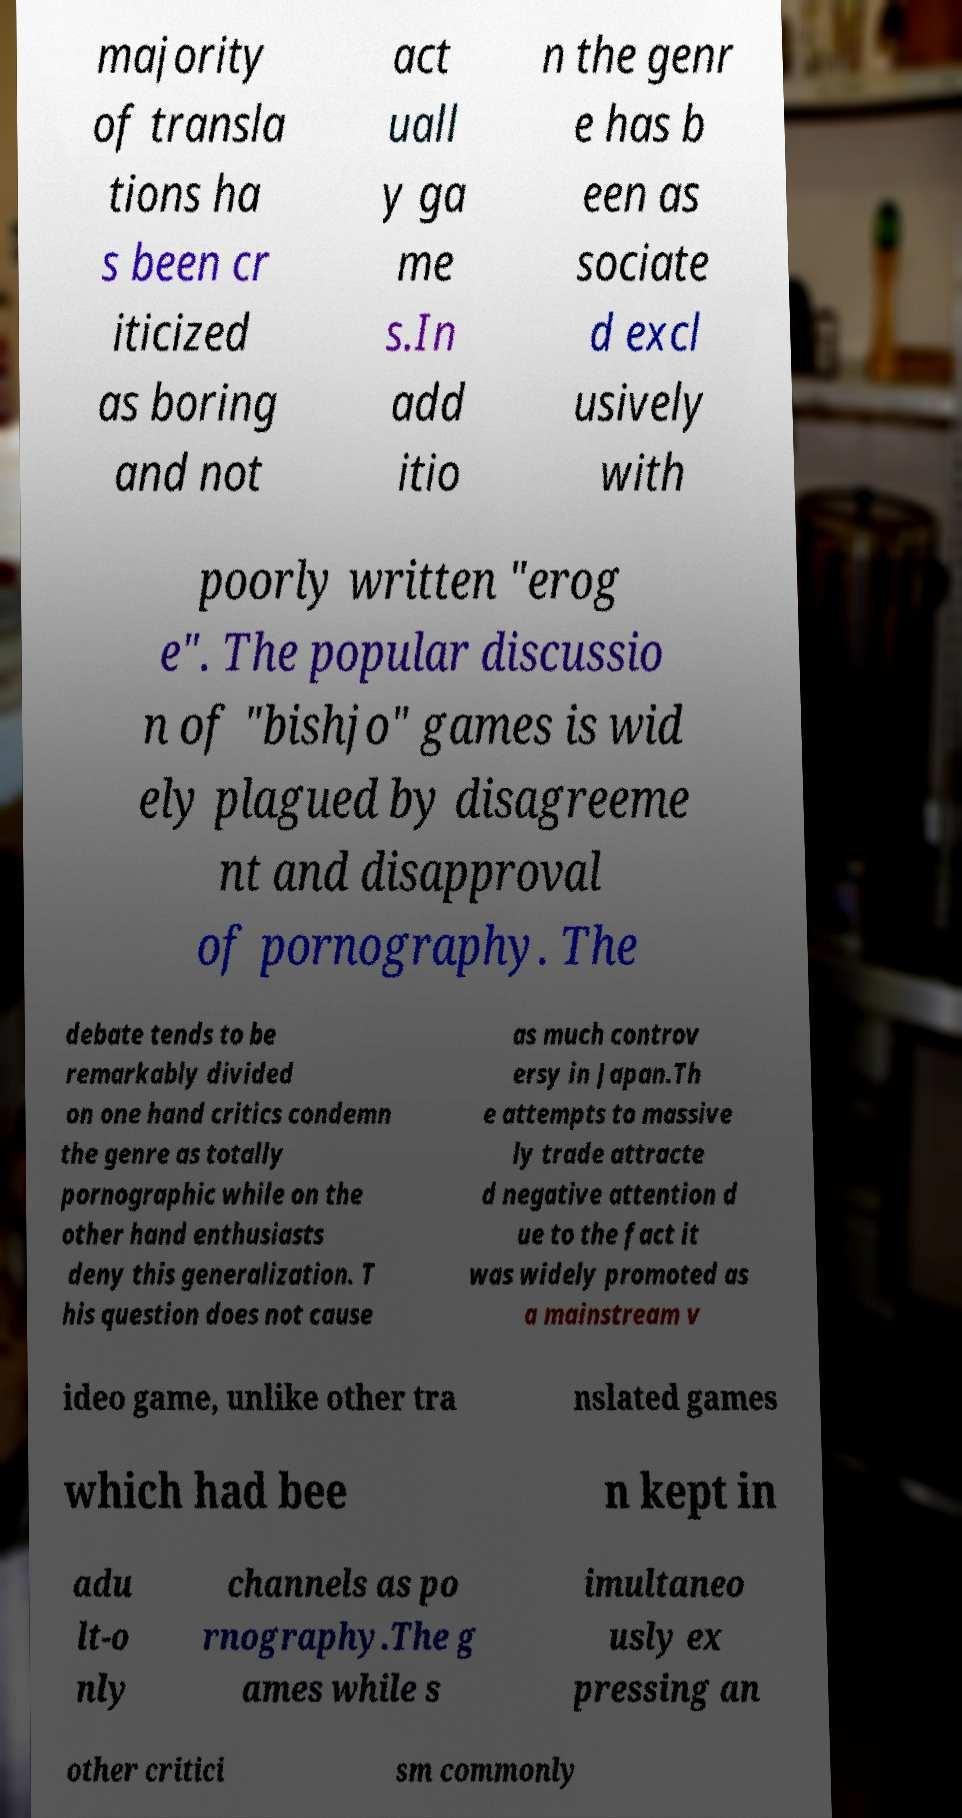Can you read and provide the text displayed in the image?This photo seems to have some interesting text. Can you extract and type it out for me? majority of transla tions ha s been cr iticized as boring and not act uall y ga me s.In add itio n the genr e has b een as sociate d excl usively with poorly written "erog e". The popular discussio n of "bishjo" games is wid ely plagued by disagreeme nt and disapproval of pornography. The debate tends to be remarkably divided on one hand critics condemn the genre as totally pornographic while on the other hand enthusiasts deny this generalization. T his question does not cause as much controv ersy in Japan.Th e attempts to massive ly trade attracte d negative attention d ue to the fact it was widely promoted as a mainstream v ideo game, unlike other tra nslated games which had bee n kept in adu lt-o nly channels as po rnography.The g ames while s imultaneo usly ex pressing an other critici sm commonly 